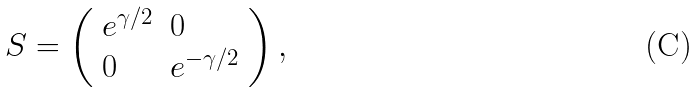Convert formula to latex. <formula><loc_0><loc_0><loc_500><loc_500>S = \left ( \begin{array} { l l } { { e ^ { \gamma / 2 } } } & { 0 } \\ { 0 } & { { e ^ { - \gamma / 2 } } } \end{array} \right ) ,</formula> 